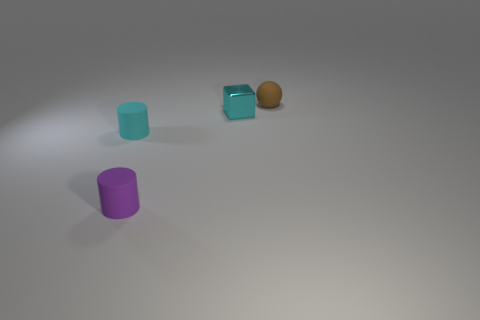Add 2 brown rubber objects. How many objects exist? 6 Add 3 brown objects. How many brown objects exist? 4 Subtract 0 cyan spheres. How many objects are left? 4 Subtract all large gray metallic things. Subtract all tiny cylinders. How many objects are left? 2 Add 3 brown rubber objects. How many brown rubber objects are left? 4 